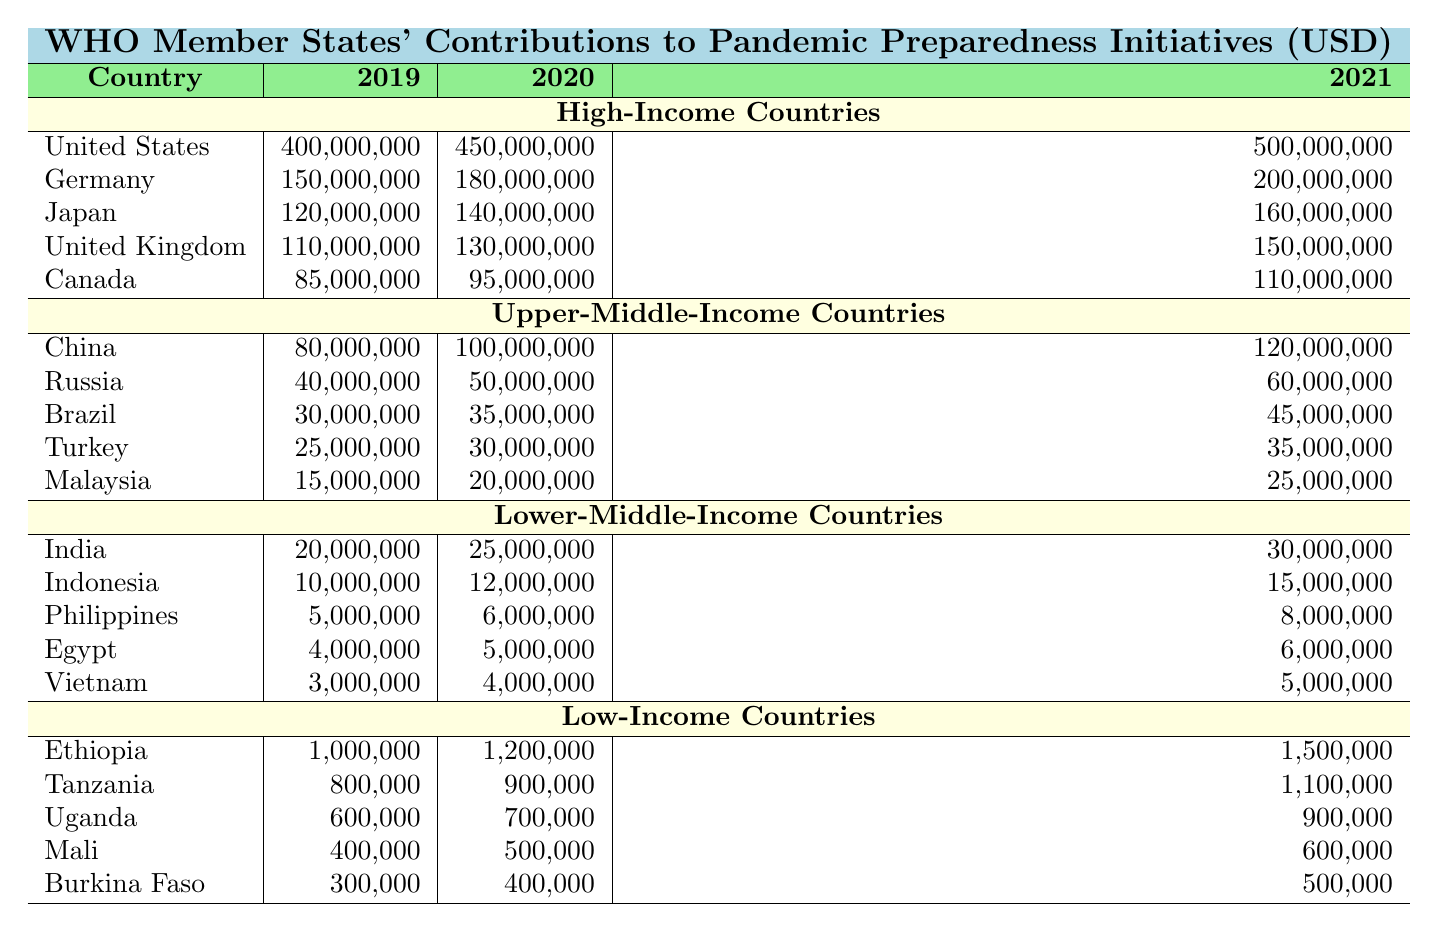What was the total contribution of the United States to pandemic preparedness initiatives from 2019 to 2021? The contributions from the United States for each year are 400,000,000 in 2019, 450,000,000 in 2020, and 500,000,000 in 2021. To find the total, sum these amounts: 400,000,000 + 450,000,000 + 500,000,000 = 1,350,000,000.
Answer: 1,350,000,000 Which country increased its contribution by the largest amount between 2019 and 2021? Looking at the contributions from each country over the two years, China had contributions of 80,000,000 in 2019 and 120,000,000 in 2021, resulting in an increase of 40,000,000. This is compared with other countries, and no country had a higher increase than this.
Answer: China What was the contribution of Lower-Middle-Income Countries in 2020? Summing the contributions of all Lower-Middle-Income Countries in 2020: India 25,000,000, Indonesia 12,000,000, Philippines 6,000,000, Egypt 5,000,000, and Vietnam 4,000,000 gives a total of 52,000,000.
Answer: 52,000,000 Which income group had the highest total contribution in 2021? The High-Income Countries' total contributions in 2021 are: 500,000,000 (US) + 200,000,000 (Germany) + 160,000,000 (Japan) + 150,000,000 (UK) + 110,000,000 (Canada) = 1,120,000,000. In comparison, it can be calculated that Upper-Middle had 275,000,000, Lower-Middle had 60,000,000, and Low-Income had 2,700,000. Thus, High-Income had the highest total.
Answer: High-Income Countries Did any Low-Income Country reduce its contribution in 2021 compared to 2020? Evaluating the contributions for Low-Income Countries: Ethiopia increased from 1,200,000 to 1,500,000, Tanzania increased from 900,000 to 1,100,000, Uganda increased from 700,000 to 900,000, Mali increased from 500,000 to 600,000, and Burkina Faso increased from 400,000 to 500,000. All contributions increased, so no reductions occurred.
Answer: No What is the average contribution of Upper-Middle-Income Countries in 2019? The contributions for Upper-Middle-Income Countries in 2019 are: China 80,000,000, Russia 40,000,000, Brazil 30,000,000, Turkey 25,000,000, Malaysia 15,000,000. The total is 80,000,000 + 40,000,000 + 30,000,000 + 25,000,000 + 15,000,000 = 190,000,000, and there are 5 countries, so the average is 190,000,000 / 5 = 38,000,000.
Answer: 38,000,000 What was the contribution of Germany in 2020 compared to 2019? Germany contributed 180,000,000 in 2020 and 150,000,000 in 2019. Thus, the contribution increased by 30,000,000 from 2019 to 2020.
Answer: Increased by 30,000,000 Which country contributed the least to pandemic preparedness initiatives in 2021? The contributions for 2021 for Low-Income Countries are: Ethiopia 1,500,000, Tanzania 1,100,000, Uganda 900,000, Mali 600,000, and Burkina Faso 500,000. The country with the least contribution is Burkina Faso with 500,000.
Answer: Burkina Faso How much more did the United States contribute compared to Canada in 2021? The United States contributed 500,000,000 in 2021, while Canada contributed 110,000,000. The difference is: 500,000,000 - 110,000,000 = 390,000,000.
Answer: 390,000,000 What is the total contribution of Low-Income Countries in 2019? Summing the contributions in 2019: Ethiopia 1,000,000, Tanzania 800,000, Uganda 600,000, Mali 400,000, Burkina Faso 300,000 gives a total of 3,100,000.
Answer: 3,100,000 